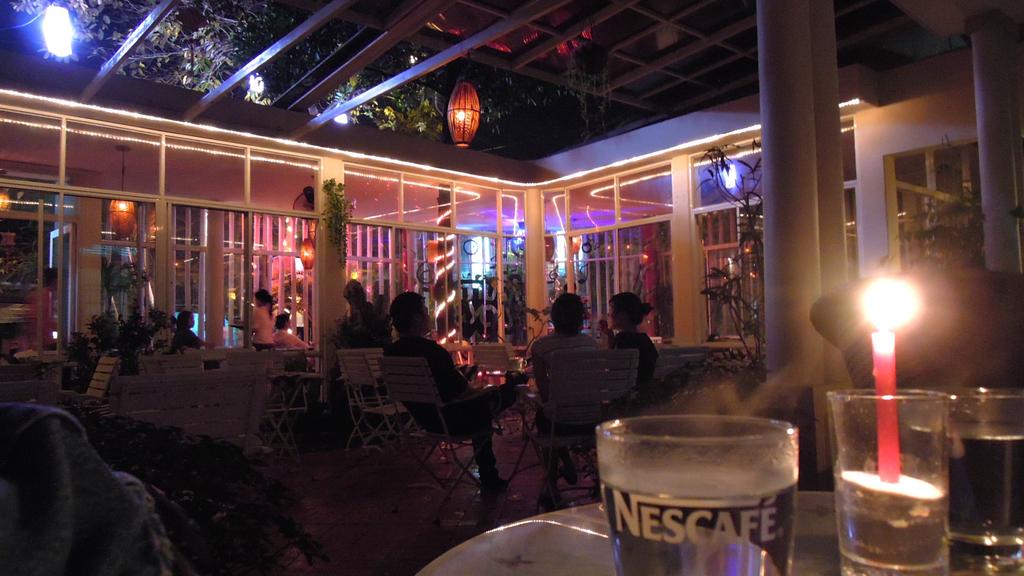What is on the cup?
Your answer should be very brief. Nescafe. 